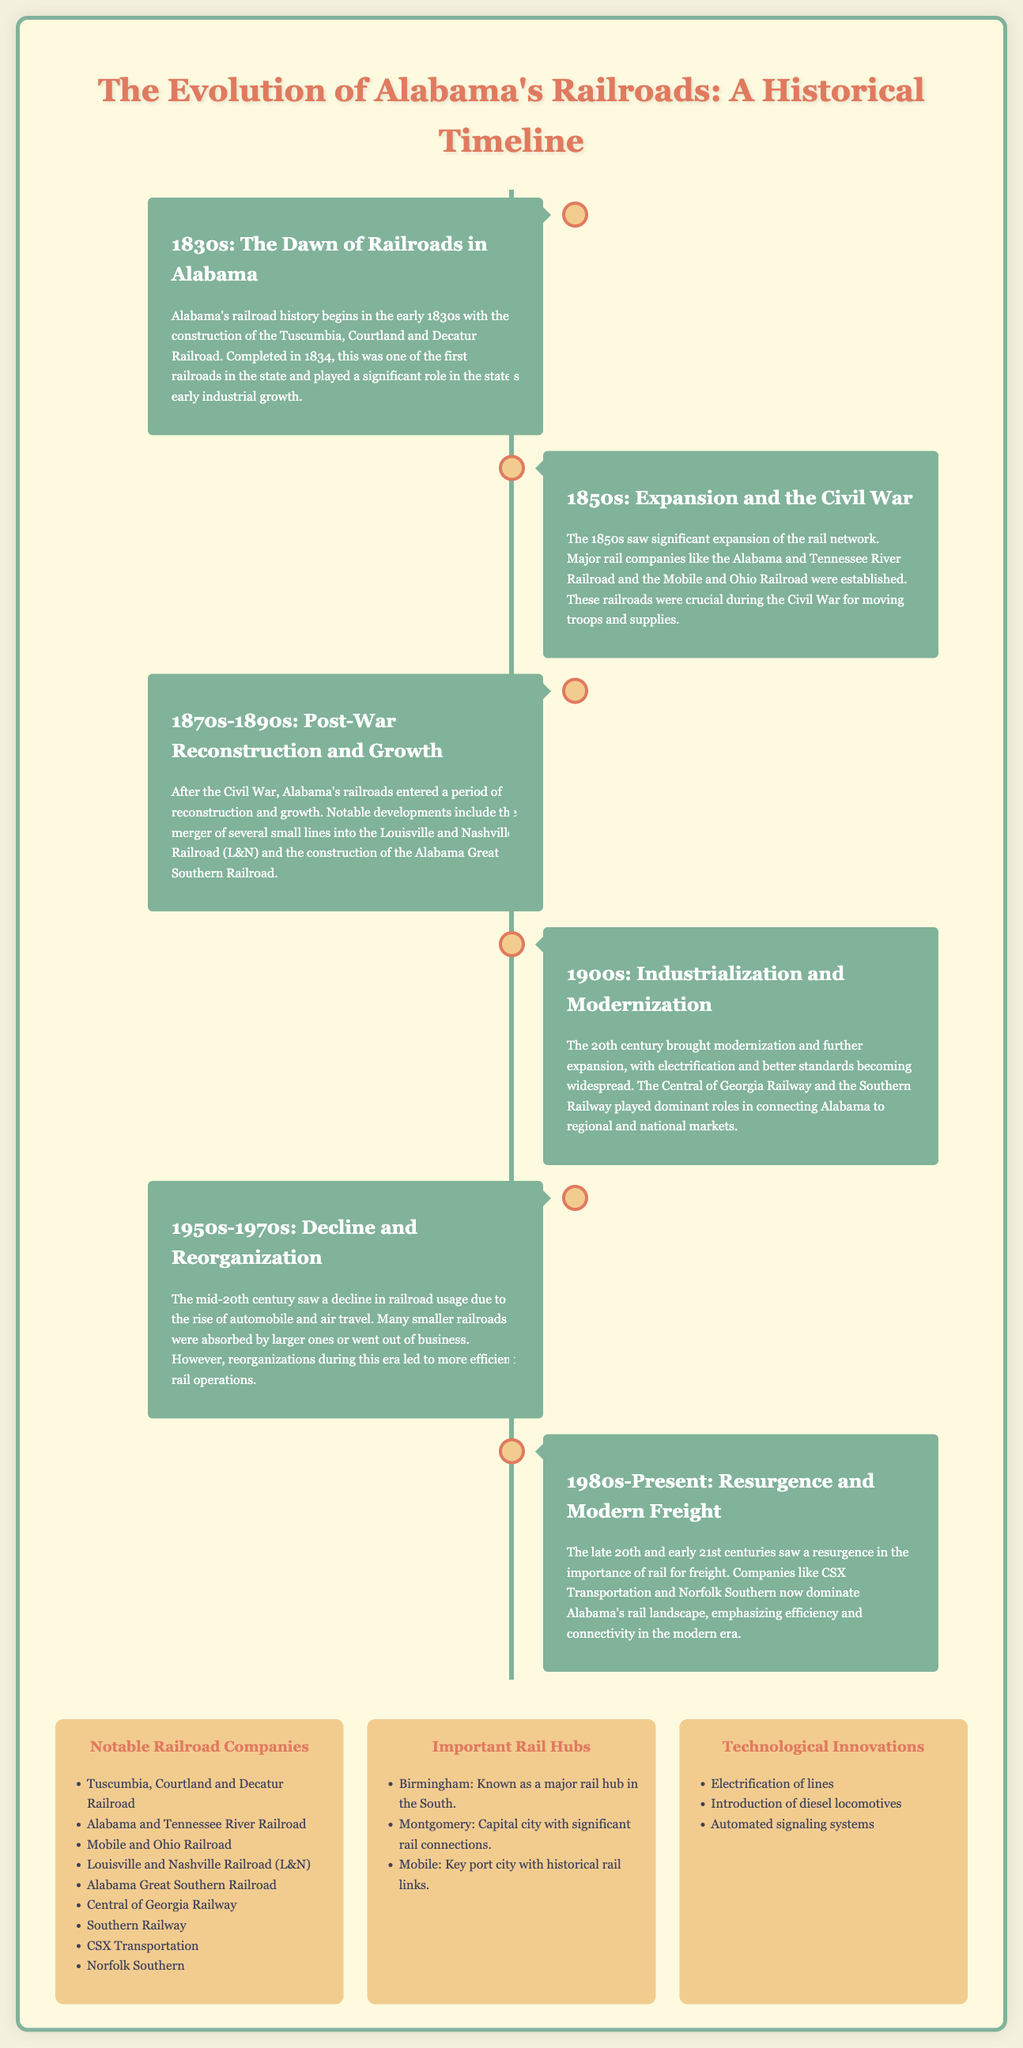What railroad began Alabama's history in the 1830s? The Tuscumbia, Courtland and Decatur Railroad is mentioned as the start of Alabama's railroad history.
Answer: Tuscumbia, Courtland and Decatur Railroad In which decade was the Louisville and Nashville Railroad (L&N) established? The document highlights notable developments in the 1870s-1890s involving the merger into the Louisville and Nashville Railroad.
Answer: 1870s-1890s Which cities are noted as important rail hubs in Alabama? The document lists Birmingham, Montgomery, and Mobile as important rail hubs.
Answer: Birmingham, Montgomery, Mobile What major factor contributed to railroad decline in the mid-20th century? The document states that the rise of automobile and air travel led to a decline in railroad usage.
Answer: Automobile and air travel Which technology was introduced during the modernization of railroads in the 1900s? The document specifies that electrification was one of the advancements during this period.
Answer: Electrification Who are the dominant companies in Alabama's rail landscape today? The document mentions CSX Transportation and Norfolk Southern as the dominant companies currently.
Answer: CSX Transportation and Norfolk Southern 